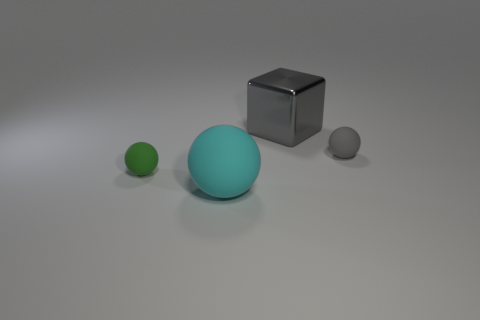Is there anything else that has the same material as the large gray block?
Provide a short and direct response. No. How many rubber objects are either large blue blocks or small gray spheres?
Your response must be concise. 1. There is a large gray object; how many balls are to the right of it?
Your response must be concise. 1. Is there a cyan rubber thing that has the same size as the green matte object?
Give a very brief answer. No. Are there any other big balls of the same color as the large matte ball?
Offer a terse response. No. Are there any other things that have the same size as the green rubber sphere?
Your response must be concise. Yes. What number of tiny rubber spheres are the same color as the cube?
Provide a succinct answer. 1. Is the color of the cube the same as the tiny ball that is in front of the tiny gray rubber ball?
Provide a succinct answer. No. How many objects are either big yellow objects or cyan matte objects in front of the green rubber thing?
Your answer should be compact. 1. How big is the matte object that is behind the small object left of the cyan thing?
Offer a very short reply. Small. 